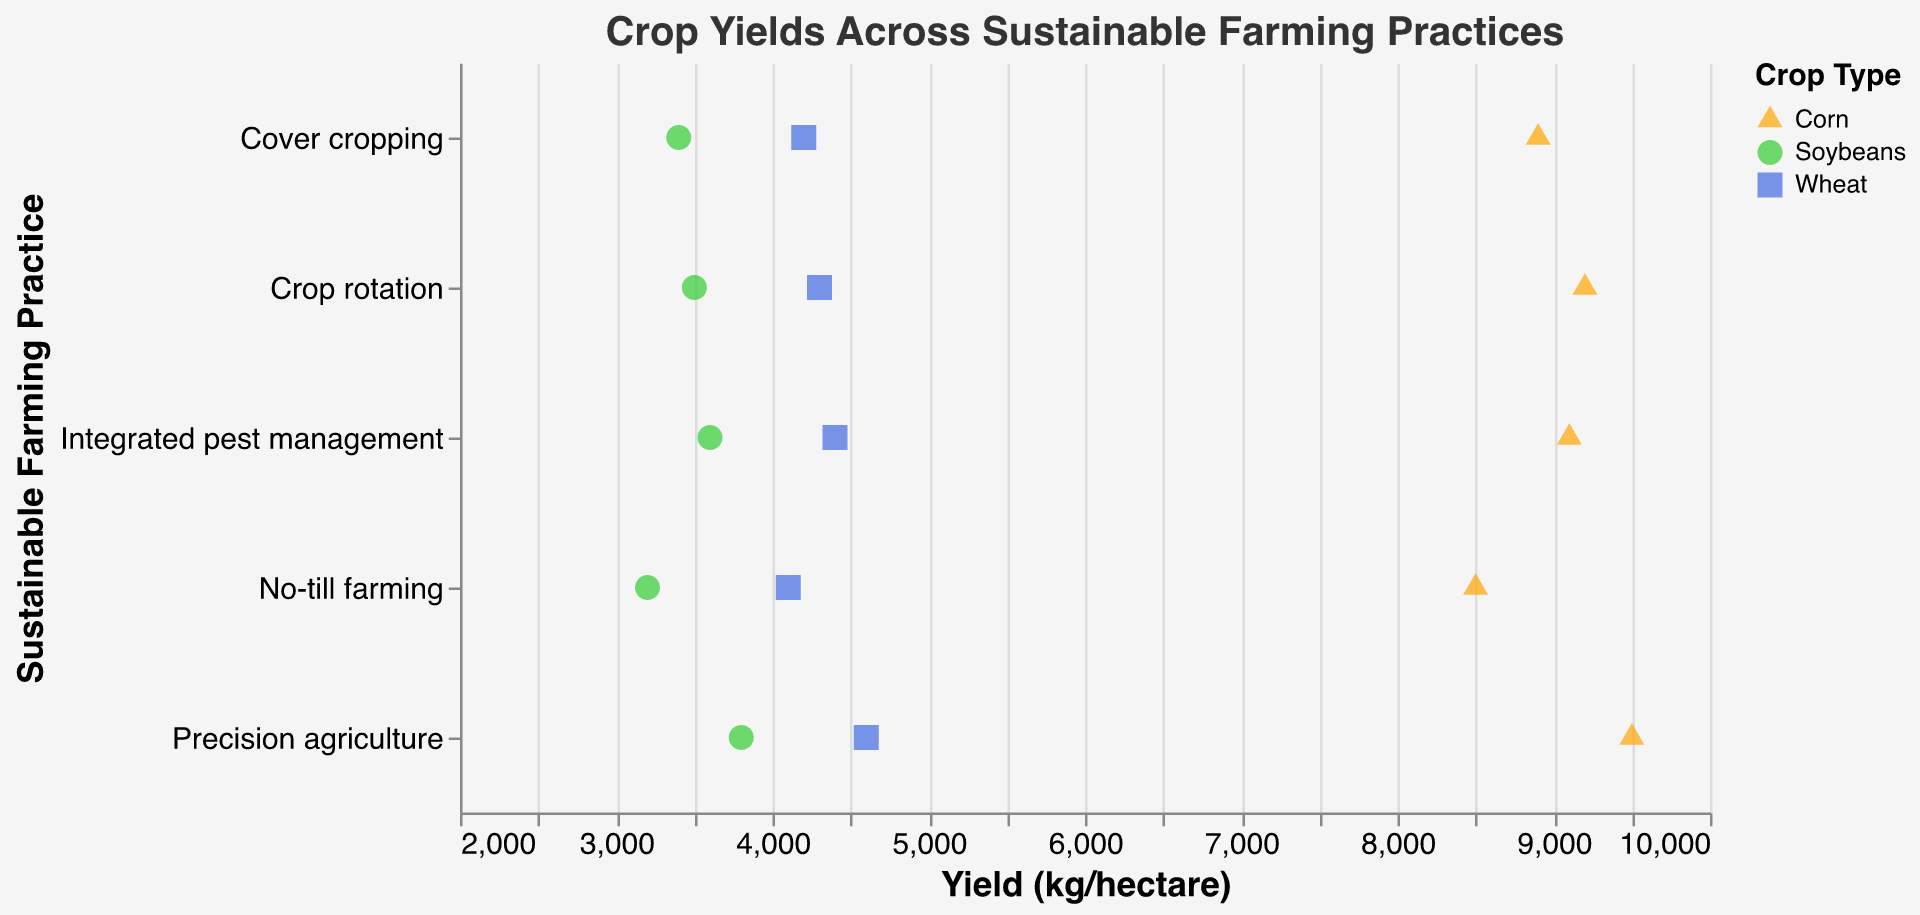What is the title of the figure? The title of the figure is displayed at the top and it reads "Crop Yields Across Sustainable Farming Practices".
Answer: Crop Yields Across Sustainable Farming Practices Which farming practice has the highest yield for Corn? Looking at the strip plot, the Corn yield is highest for Precision agriculture, with a value of 9500 kg/hectare.
Answer: Precision agriculture What is the range of yields for Wheat across all farming practices? The lowest yield for Wheat is 4100 kg/hectare (No-till farming) and the highest is 4600 kg/hectare (Precision agriculture). Therefore, the range is 4600 - 4100 = 500 kg/hectare.
Answer: 500 kg/hectare Compare the yields of Soybeans using Crop rotation and Integrated pest management. Which one is higher? The yield for Soybeans using Crop rotation is 3500 kg/hectare, while with Integrated pest management it is 3600 kg/hectare. Therefore, Integrated pest management has a higher yield.
Answer: Integrated pest management How many data points are there in total for each crop type? Each crop type (Corn, Soybeans, Wheat) has data points for five farming practices, which sums up to 3 crops * 5 practices = 15 data points.
Answer: 15 What is the average yield for Soybeans across all farming practices? The yields for Soybeans across all farming practices are: 3200, 3500, 3400, 3600, and 3800 kg/hectare. The average can be calculated as (3200 + 3500 + 3400 + 3600 + 3800) / 5 = 3500 kg/hectare.
Answer: 3500 kg/hectare Which farming practice shows the least variation in crop yields? To find the farming practice with the least variation, observe the spread of yield values within each practice. No-till farming has yields close to 4100, 3200, and 8500, while Precision agriculture has values close to 9500, 3800, and 4600. The least spread is seen in Precision agriculture where crop yields are more clustered together.
Answer: Precision agriculture Are there any crop types that consistently perform better or worse across all farming practices? Precision agriculture consistently shows the highest yields across Corn, Soybeans, and Wheat compared to other practices.
Answer: Precision agriculture 